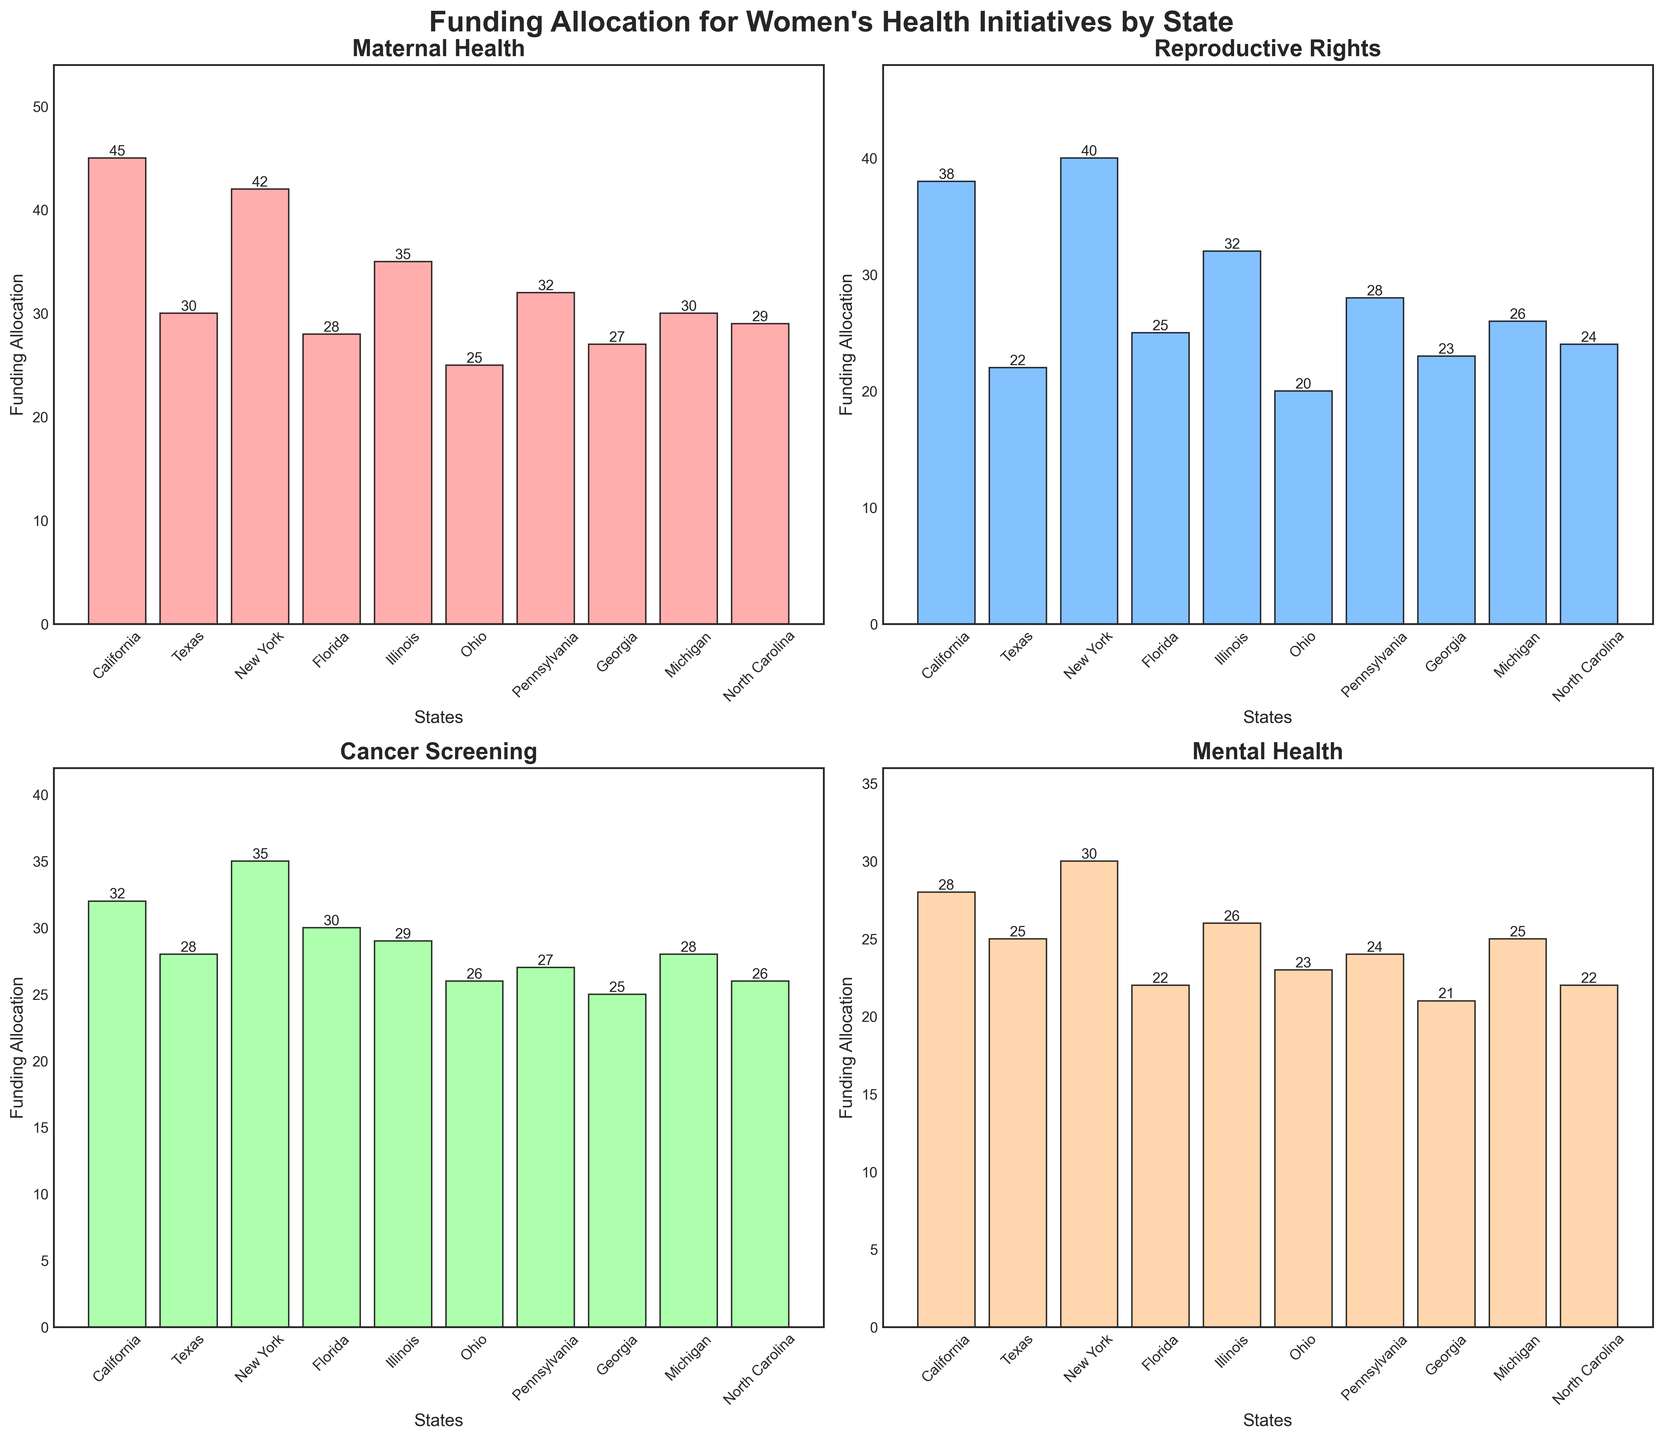What is the title of the figure? The title is usually indicated at the top of the chart. In this figure, it is stated at the top in bold letters.
Answer: Funding Allocation for Women's Health Initiatives by State Which state has the highest funding for Maternal Health? Look at the bar chart for Maternal Health, identify the tallest bar and its corresponding state.
Answer: California What is the funding allocation for Cancer Screening in New York? Locate the bar chart for Cancer Screening, find the bar associated with the state New York, and read off the height.
Answer: 35 Which category has the lowest funding allocation in Florida? Examine the bars in each category for Florida and identify the bar with the shortest height.
Answer: Mental Health What is the difference in funding allocation between Maternal Health and Reproductive Rights in Texas? For Texas, subtract the height of the Reproductive Rights bar from the height of the Maternal Health bar.
Answer: 8 What is the average funding allocation for Michigan across all categories? Sum the funding allocations for Michigan in all categories and divide by the number of categories (4). Calculation: (30 + 26 + 28 + 25) / 4 = 27.25
Answer: 27.25 For which category does Ohio have the least funding compared to New York? Compare the funding allocations for Ohio and New York in each category and identify where the difference is the largest with Ohio having less.
Answer: Reproductive Rights Which state has the second-highest funding allocation for Mental Health? Rank the states by the height of the bars in the Mental Health category and determine the second-highest.
Answer: New York What is the sum of funding allocation for Reproductive Rights in California, Texas, and Illinois? Add the Reproductive Rights funding allocations for California, Texas, and Illinois: 38 (California) + 22 (Texas) + 32 (Illinois) = 92
Answer: 92 Which two categories have the closest funding allocation in Georgia? Compare the heights of the bars for each category in Georgia and identify the two with the smallest difference.
Answer: Reproductive Rights and Cancer Screening 